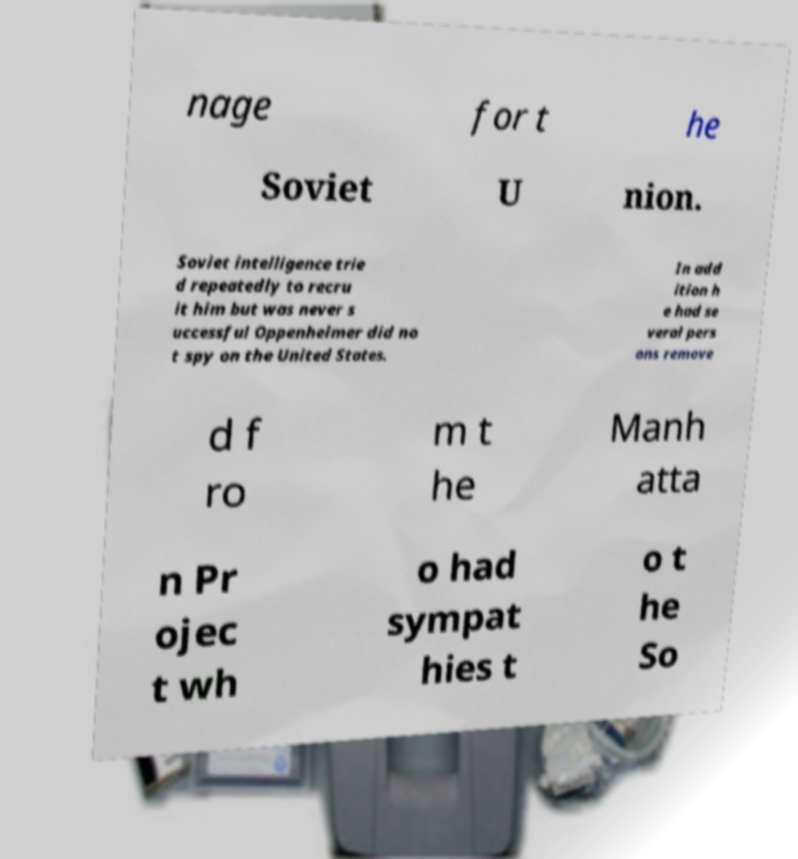I need the written content from this picture converted into text. Can you do that? nage for t he Soviet U nion. Soviet intelligence trie d repeatedly to recru it him but was never s uccessful Oppenheimer did no t spy on the United States. In add ition h e had se veral pers ons remove d f ro m t he Manh atta n Pr ojec t wh o had sympat hies t o t he So 